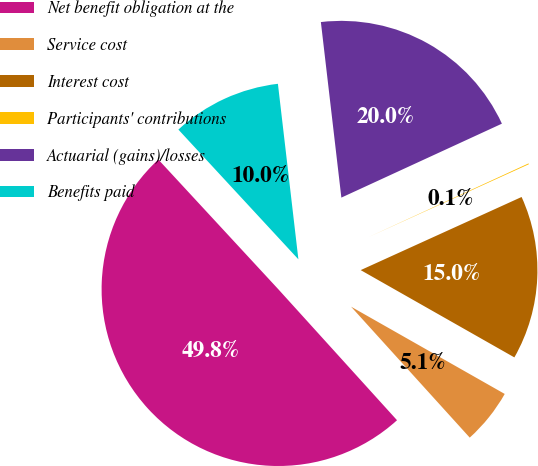Convert chart. <chart><loc_0><loc_0><loc_500><loc_500><pie_chart><fcel>Net benefit obligation at the<fcel>Service cost<fcel>Interest cost<fcel>Participants' contributions<fcel>Actuarial (gains)/losses<fcel>Benefits paid<nl><fcel>49.84%<fcel>5.06%<fcel>15.01%<fcel>0.08%<fcel>19.98%<fcel>10.03%<nl></chart> 